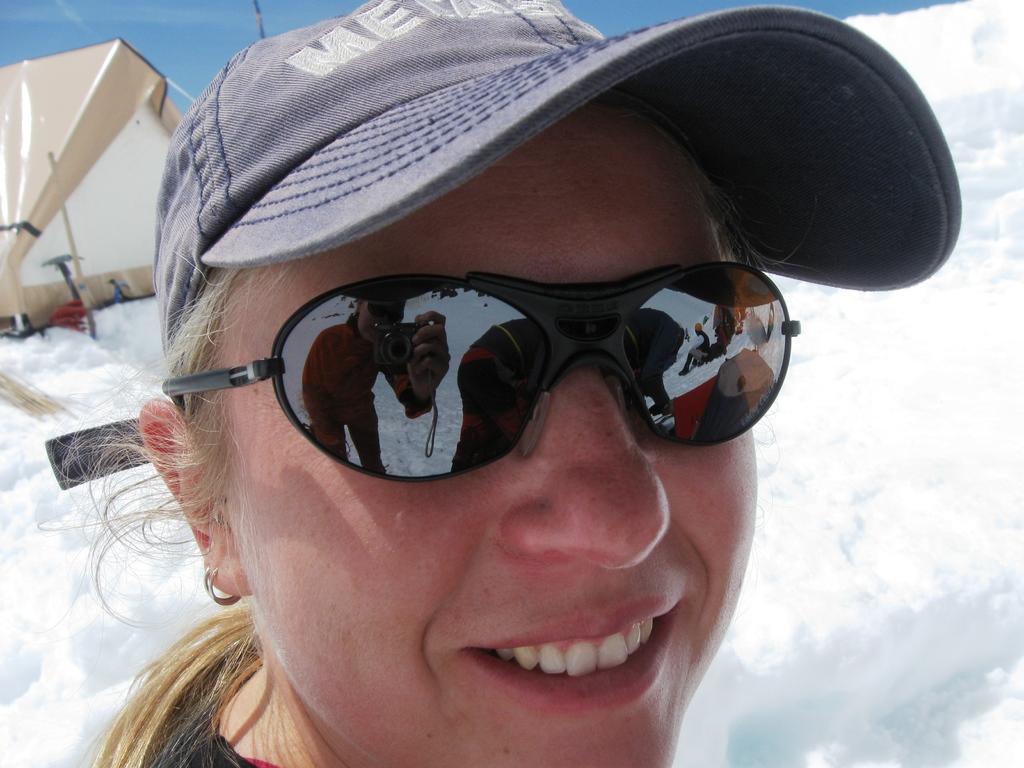How would you summarize this image in a sentence or two? In this picture we can see a woman with the goggles and a cap. Behind the woman there is snow, tent and the sky. On the goggles we can see the reflection of a person holding a camera. 